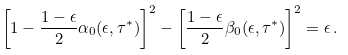<formula> <loc_0><loc_0><loc_500><loc_500>\left [ 1 - \frac { 1 - \epsilon } { 2 } \alpha _ { 0 } ( \epsilon , \tau ^ { * } ) \right ] ^ { 2 } - \left [ \frac { 1 - \epsilon } { 2 } \beta _ { 0 } ( \epsilon , \tau ^ { * } ) \right ] ^ { 2 } = \epsilon \, .</formula> 